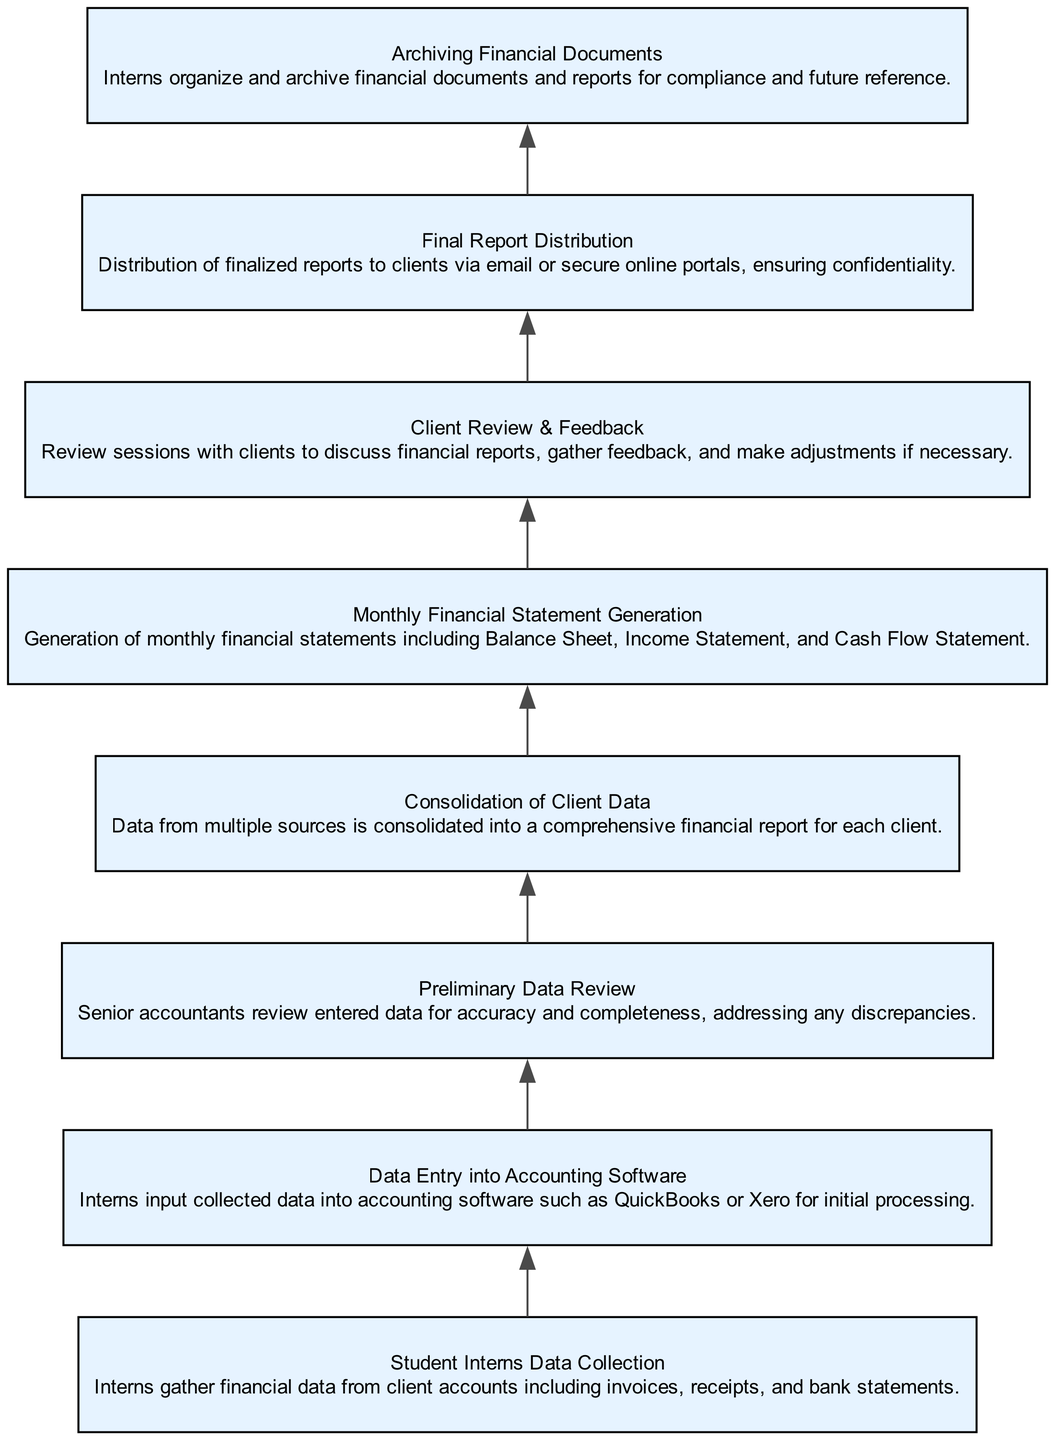What is the first step in the Monthly Financial Reporting Process? The first step listed in the diagram is "Student Interns Data Collection," which indicates that interns initially gather financial data from client accounts.
Answer: Student Interns Data Collection How many steps are in the Monthly Financial Reporting Process? By counting the elements in the diagram, there are eight distinct steps that describe the entire financial reporting process.
Answer: Eight What happens after Data Entry into Accounting Software? According to the flow chart, after the step "Data Entry into Accounting Software," the next step is "Preliminary Data Review," where senior accountants check the accuracy of the entered data.
Answer: Preliminary Data Review What type of reports are generated in the Monthly Financial Statement Generation step? The output of the "Monthly Financial Statement Generation" includes several report types, specifically the Balance Sheet, Income Statement, and Cash Flow Statement, as stated in the description.
Answer: Balance Sheet, Income Statement, Cash Flow Statement What is the final action taken in the process? The last step in the diagram is "Final Report Distribution," which involves sending the finalized financial reports to clients, ensuring confidentiality through various means.
Answer: Final Report Distribution What is the relationship between Client Review & Feedback and Final Report Distribution? The flow chart indicates a sequential relationship where "Client Review & Feedback" occurs before "Final Report Distribution." This means that clients first review the reports and provide feedback before the final reports are distributed.
Answer: Sequential Relationship Which step involves feedback and possible adjustments? The step explicitly mentioned as involving client interaction for feedback and adjustments is "Client Review & Feedback." It’s where discussions about financial reports take place.
Answer: Client Review & Feedback What do interns do after the reports are generated? According to the process, after the generation of financial reports, interns engage in "Archiving Financial Documents," which involves organizing and storing the financial documents for compliance and future reference.
Answer: Archiving Financial Documents 